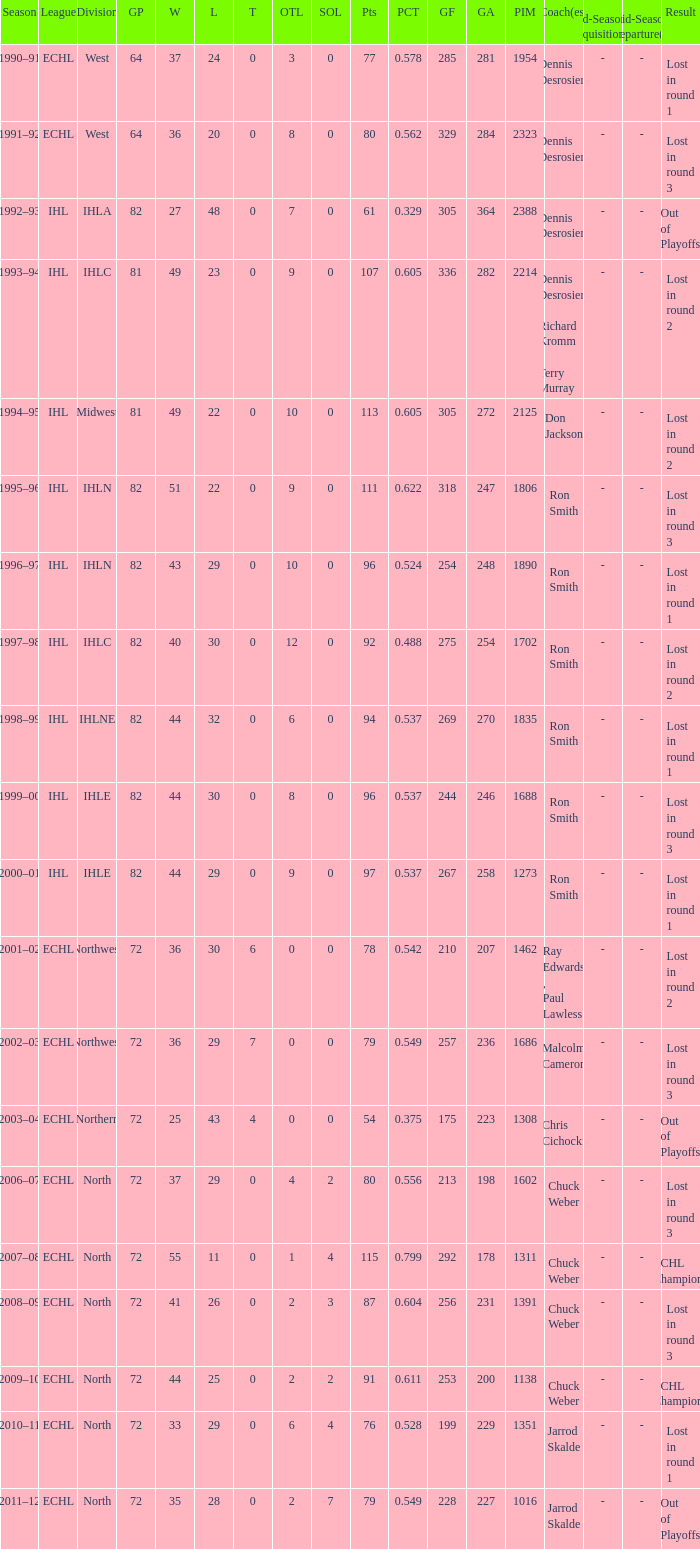What was the minimum L if the GA is 272? 22.0. 